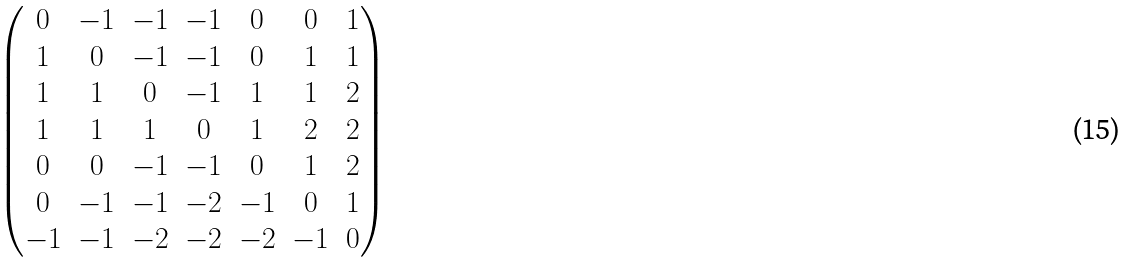Convert formula to latex. <formula><loc_0><loc_0><loc_500><loc_500>\begin{pmatrix} 0 & - 1 & - 1 & - 1 & 0 & 0 & 1 \\ 1 & 0 & - 1 & - 1 & 0 & 1 & 1 \\ 1 & 1 & 0 & - 1 & 1 & 1 & 2 \\ 1 & 1 & 1 & 0 & 1 & 2 & 2 \\ 0 & 0 & - 1 & - 1 & 0 & 1 & 2 \\ 0 & - 1 & - 1 & - 2 & - 1 & 0 & 1 \\ - 1 & - 1 & - 2 & - 2 & - 2 & - 1 & 0 \end{pmatrix}</formula> 